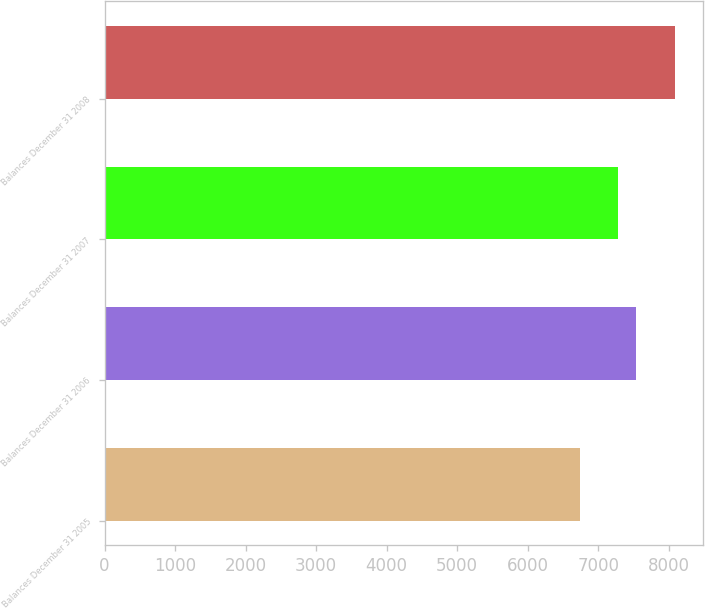<chart> <loc_0><loc_0><loc_500><loc_500><bar_chart><fcel>Balances December 31 2005<fcel>Balances December 31 2006<fcel>Balances December 31 2007<fcel>Balances December 31 2008<nl><fcel>6737<fcel>7539<fcel>7275<fcel>8089<nl></chart> 